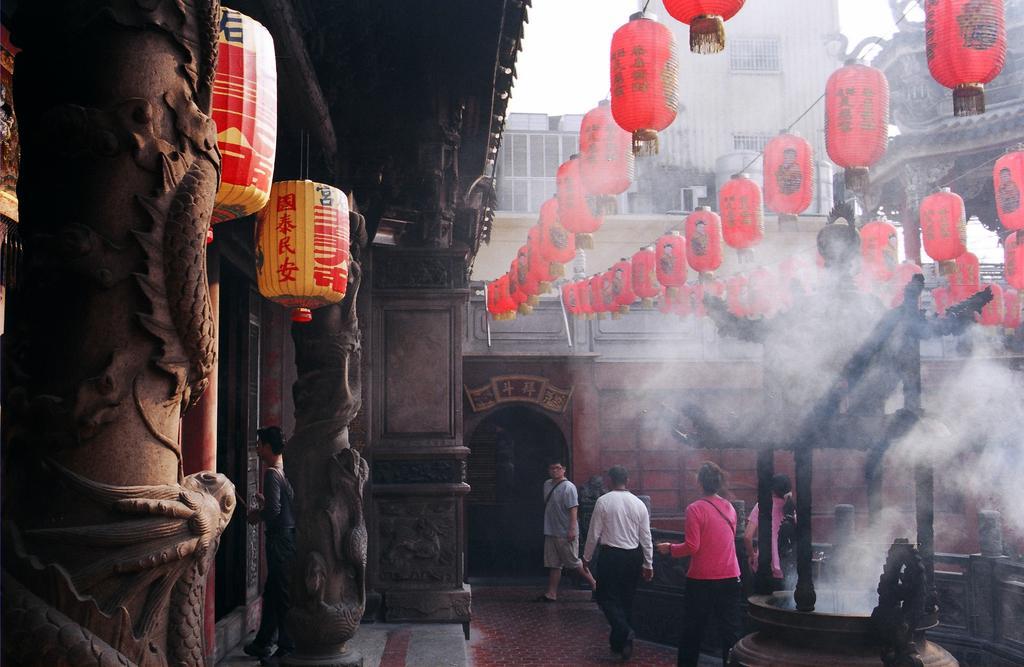How would you summarize this image in a sentence or two? In this picture I can see few buildings in front and I can see number of Chinese lanterns and on the bottom side of this picture, I can see few people on the path and I can see the smoke. 